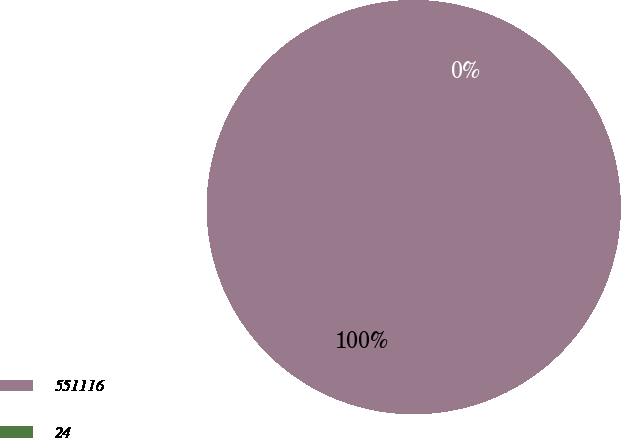<chart> <loc_0><loc_0><loc_500><loc_500><pie_chart><fcel>551116<fcel>24<nl><fcel>100.0%<fcel>0.0%<nl></chart> 